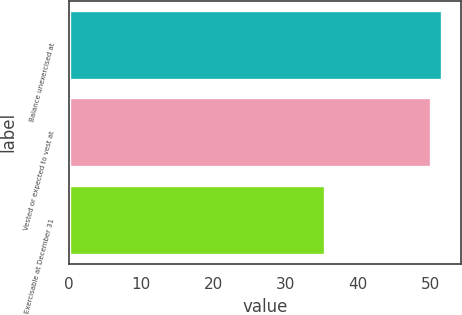<chart> <loc_0><loc_0><loc_500><loc_500><bar_chart><fcel>Balance unexercised at<fcel>Vested or expected to vest at<fcel>Exercisable at December 31<nl><fcel>51.64<fcel>50.1<fcel>35.4<nl></chart> 